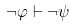Convert formula to latex. <formula><loc_0><loc_0><loc_500><loc_500>\neg \varphi \vdash \neg \psi</formula> 